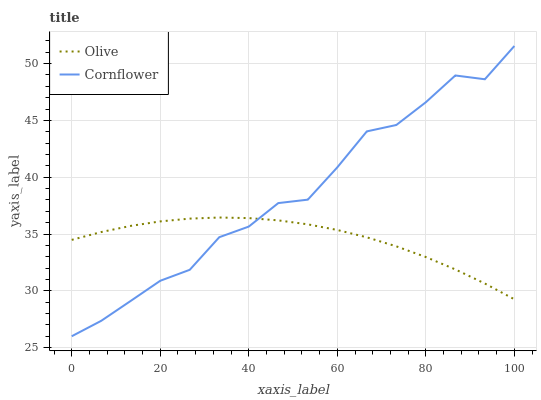Does Cornflower have the minimum area under the curve?
Answer yes or no. No. Is Cornflower the smoothest?
Answer yes or no. No. 